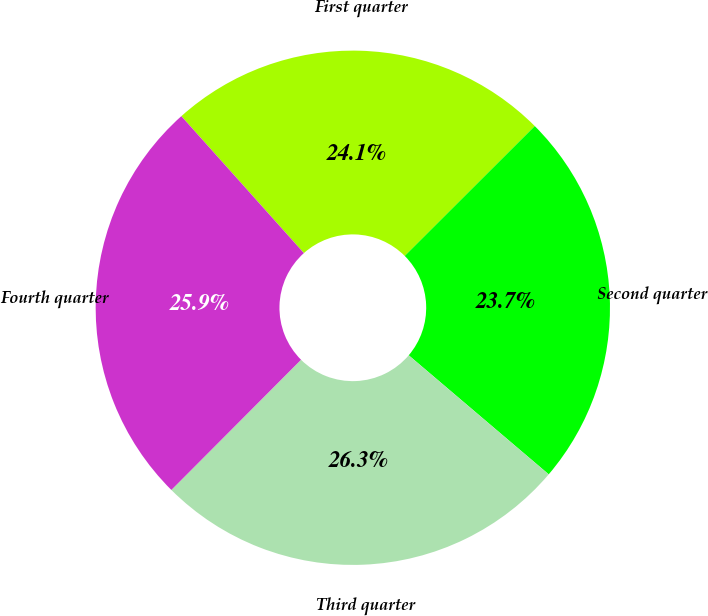Convert chart. <chart><loc_0><loc_0><loc_500><loc_500><pie_chart><fcel>First quarter<fcel>Second quarter<fcel>Third quarter<fcel>Fourth quarter<nl><fcel>24.13%<fcel>23.7%<fcel>26.25%<fcel>25.91%<nl></chart> 